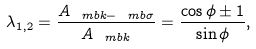<formula> <loc_0><loc_0><loc_500><loc_500>\lambda _ { 1 , 2 } = \frac { A _ { \ m b { k } - \ m b { \sigma } } } { A _ { \ m b { k } } } = \frac { \cos \phi \pm 1 } { \sin \phi } ,</formula> 